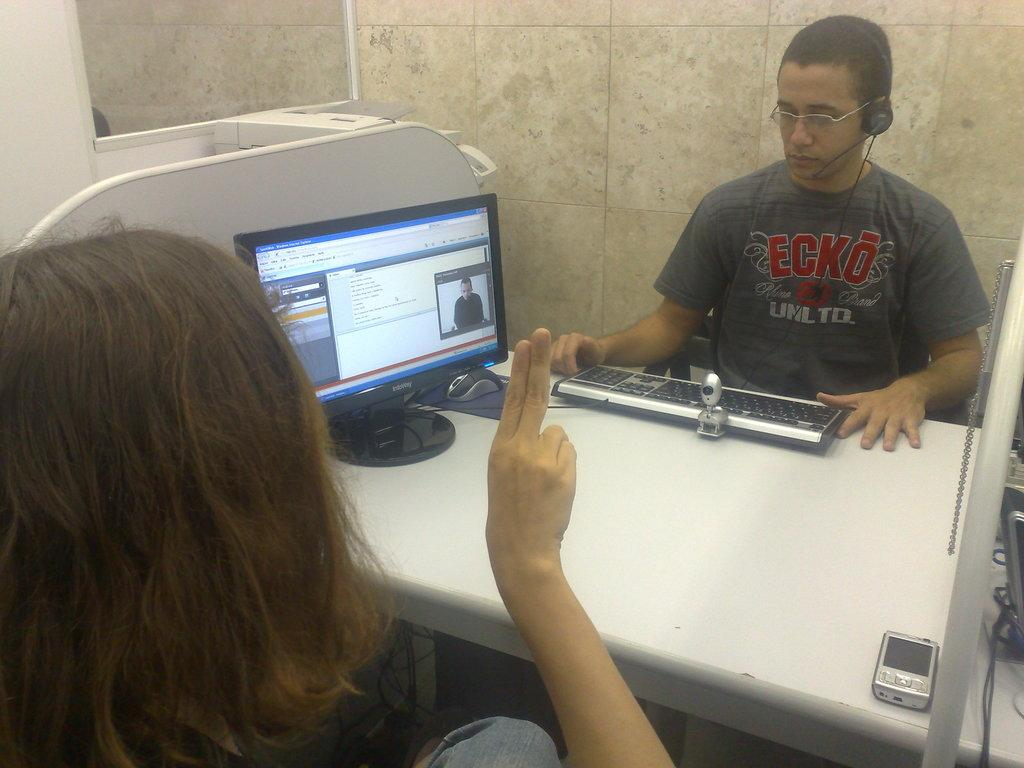Provide a one-sentence caption for the provided image. Two people talking over a work station with the male worker wearing a t-shirt that says Ecko. 